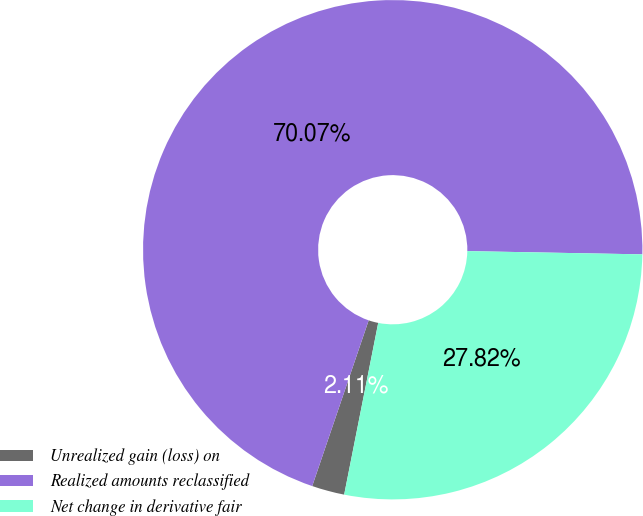Convert chart. <chart><loc_0><loc_0><loc_500><loc_500><pie_chart><fcel>Unrealized gain (loss) on<fcel>Realized amounts reclassified<fcel>Net change in derivative fair<nl><fcel>2.11%<fcel>70.07%<fcel>27.82%<nl></chart> 